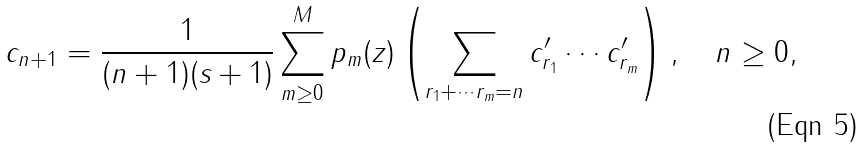<formula> <loc_0><loc_0><loc_500><loc_500>c _ { n + 1 } = \frac { 1 } { ( n + 1 ) ( s + 1 ) } \sum _ { m \geq 0 } ^ { M } p _ { m } ( z ) \left ( \sum _ { r _ { 1 } + \cdots r _ { m } = n } c ^ { \prime } _ { r _ { 1 } } \cdots c ^ { \prime } _ { r _ { m } } \right ) , \quad n \geq 0 ,</formula> 